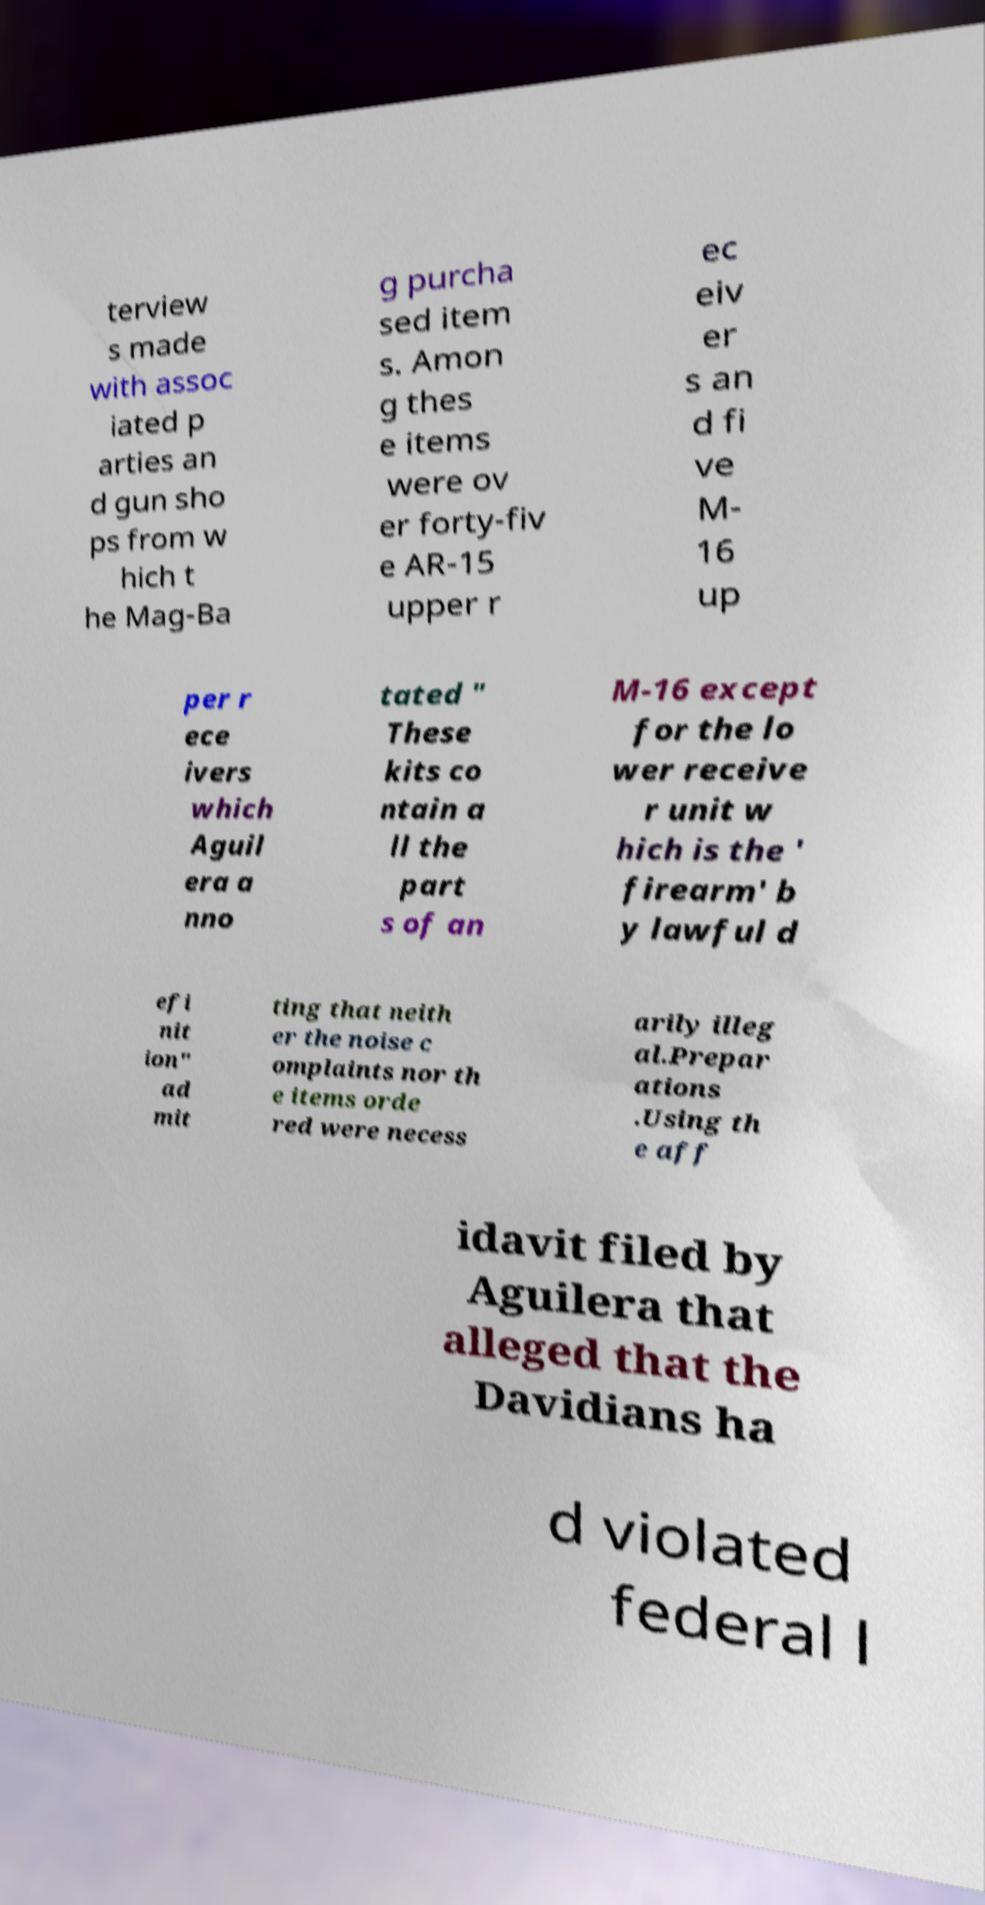There's text embedded in this image that I need extracted. Can you transcribe it verbatim? terview s made with assoc iated p arties an d gun sho ps from w hich t he Mag-Ba g purcha sed item s. Amon g thes e items were ov er forty-fiv e AR-15 upper r ec eiv er s an d fi ve M- 16 up per r ece ivers which Aguil era a nno tated " These kits co ntain a ll the part s of an M-16 except for the lo wer receive r unit w hich is the ' firearm' b y lawful d efi nit ion" ad mit ting that neith er the noise c omplaints nor th e items orde red were necess arily illeg al.Prepar ations .Using th e aff idavit filed by Aguilera that alleged that the Davidians ha d violated federal l 